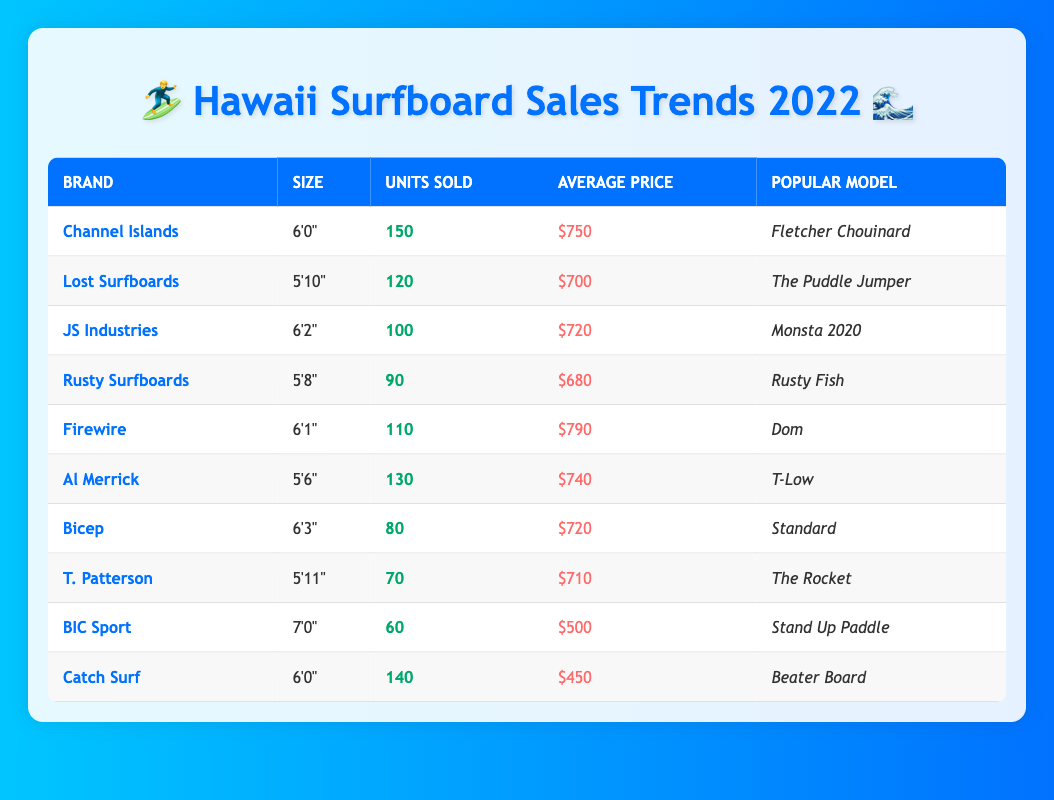What brand sold the most surfboards in Hawaii? Looking at the "Units Sold" column, Channel Islands has the highest value of 150 units sold.
Answer: Channel Islands What is the average price of surfboards sold by Rusty Surfboards? The average price listed for Rusty Surfboards in the "Average Price" column is $680.
Answer: $680 Which surfboard size had the lowest units sold? By checking the "Units Sold" column, Bicep with 80 units sold is the lowest value.
Answer: 6'3" How many more units did Channel Islands sell compared to Catch Surf? Channel Islands sold 150 units and Catch Surf sold 140 units. The difference is 150 - 140 = 10 units.
Answer: 10 units What is the total number of surfboards sold by Al Merrick and JS Industries? Adding units sold for both brands: Al Merrick sold 130 units and JS Industries sold 100 units; so, 130 + 100 = 230 units total.
Answer: 230 units True or False: The popular model for Firewire is "Beater Board." The popular model for Firewire is "Dom," as seen in the corresponding row, which makes the statement false.
Answer: False What is the average units sold for surfboards that are 6'0"? Channel Islands sold 150 units and Catch Surf sold 140 units. The average is (150 + 140) / 2 = 145 units.
Answer: 145 units Which brand had the most units sold for the surfboard size of 6'0"? Channel Islands has 150 units sold for the size of 6'0", which is more than Catch Surf's 140 units.
Answer: Channel Islands What is the price difference between the most expensive surfboard and the cheapest one? The most expensive, Firewire, costs $790 and the cheapest, BIC Sport, costs $500. The difference is $790 - $500 = $290.
Answer: $290 Which brand has the highest average price, and what is that price? Firewire has the highest average price listed at $790.
Answer: Firewire, $790 